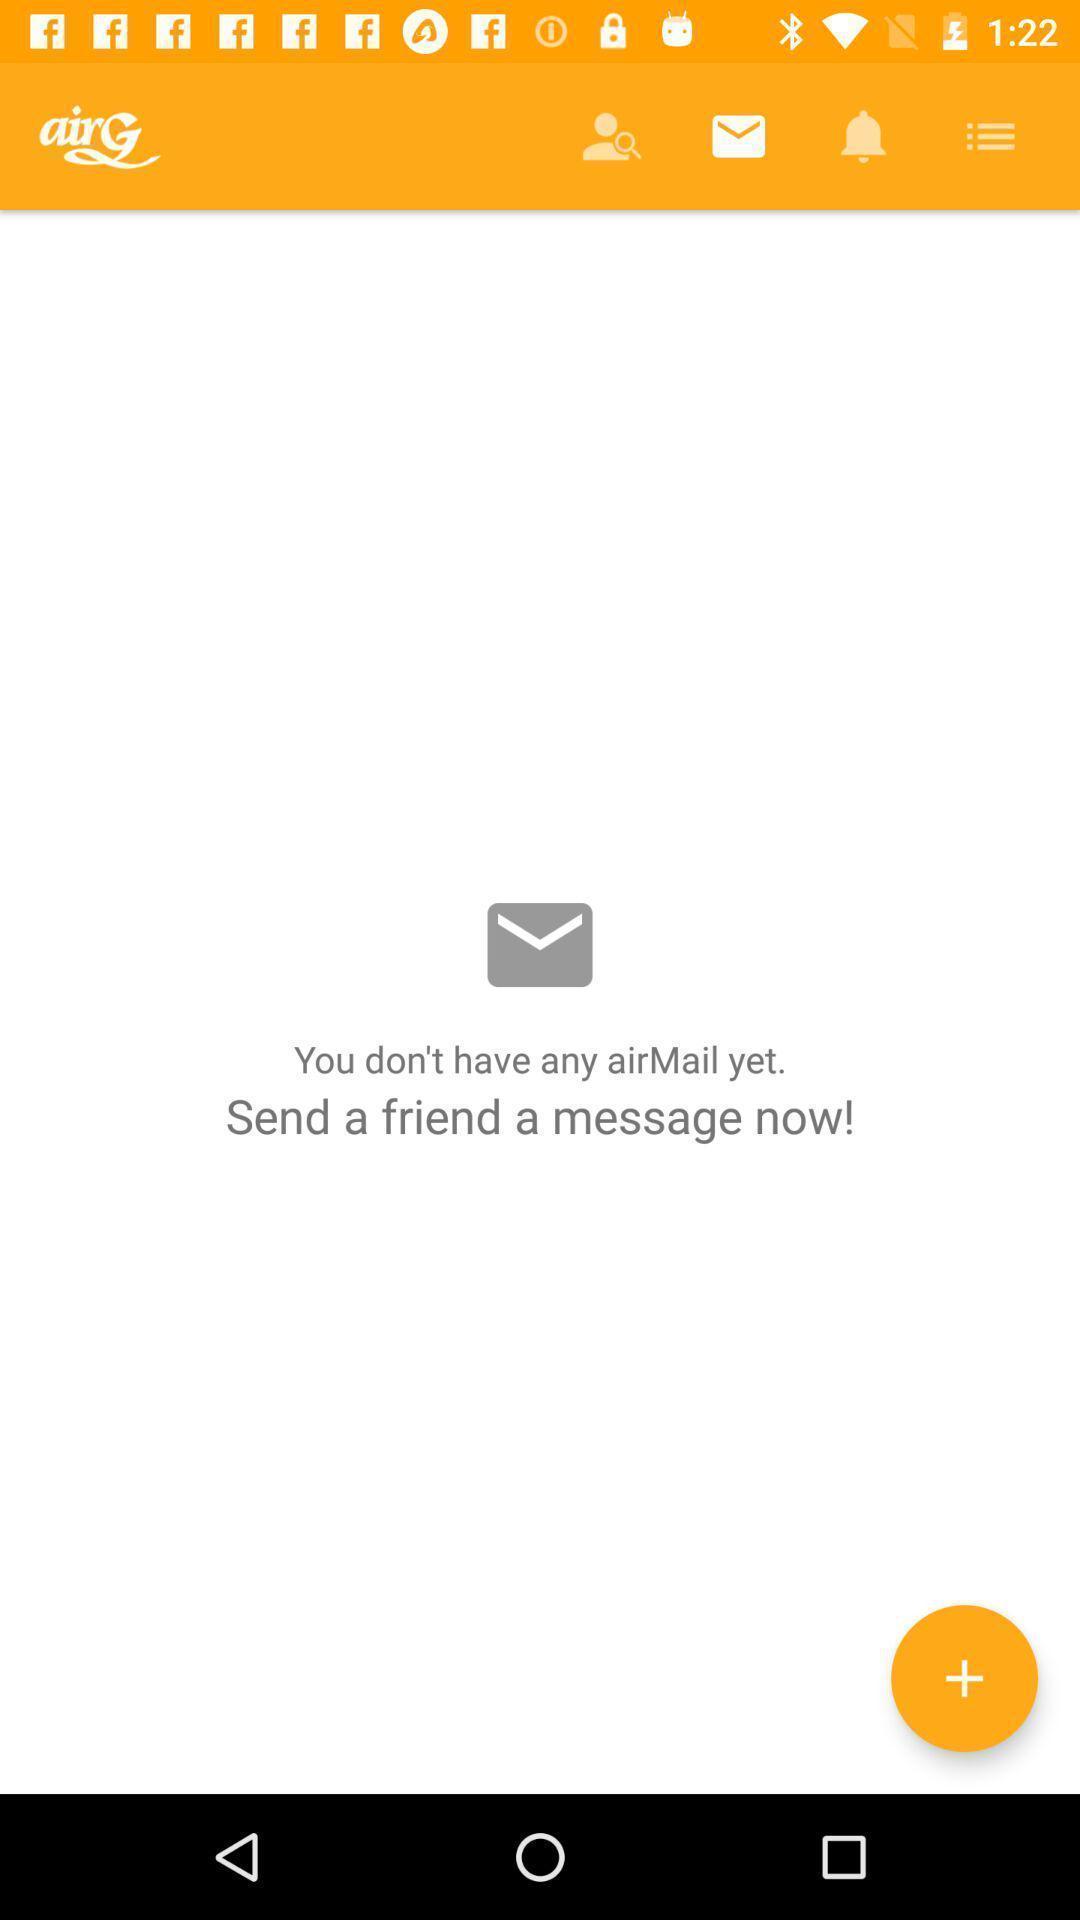Summarize the information in this screenshot. Page displaying with no messages and option to start new. 